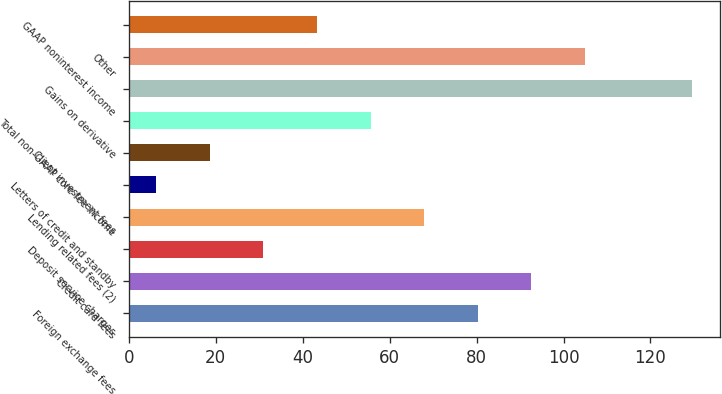<chart> <loc_0><loc_0><loc_500><loc_500><bar_chart><fcel>Foreign exchange fees<fcel>Credit card fees<fcel>Deposit service charges<fcel>Lending related fees (2)<fcel>Letters of credit and standby<fcel>Client investment fees<fcel>Total non-GAAP core fee income<fcel>Gains on derivative<fcel>Other<fcel>GAAP noninterest income<nl><fcel>80.28<fcel>92.61<fcel>30.96<fcel>67.95<fcel>6.3<fcel>18.63<fcel>55.62<fcel>129.6<fcel>104.94<fcel>43.29<nl></chart> 